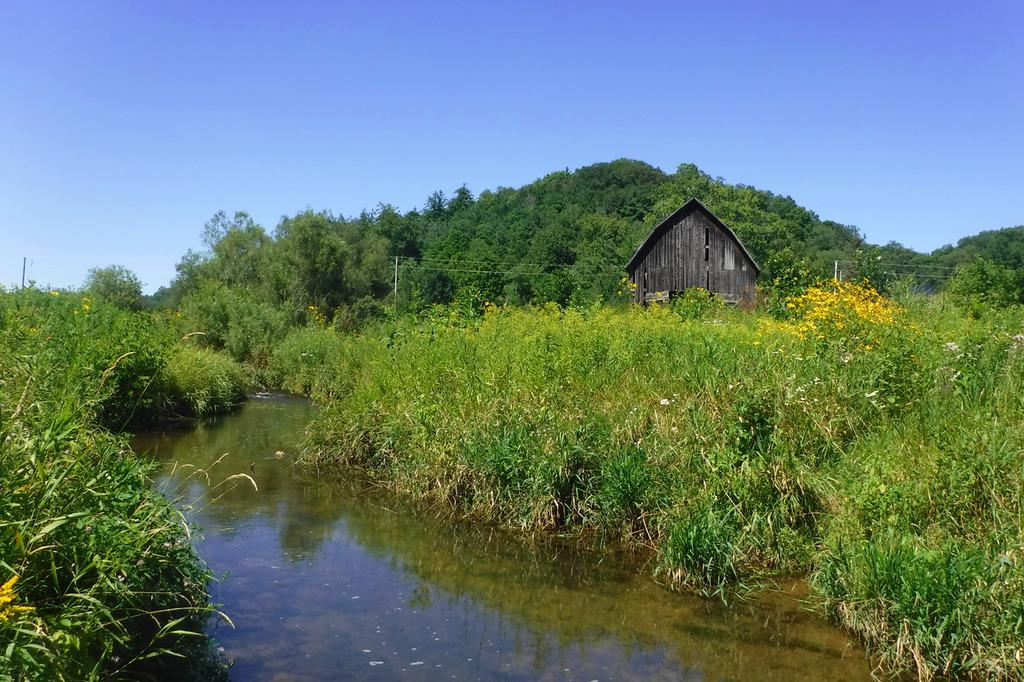What type of vegetation can be seen in the image? There are trees and plants in green color in the image. Where is the house located in the image? The house is in gray color on the left side of the image. What color is the sky in the background of the image? The sky is visible in the background of the image, and it is blue in color. Is there a faucet visible in the image? No, there is no faucet present in the image. How does the rainstorm affect the trees and plants in the image? There is no rainstorm present in the image. 